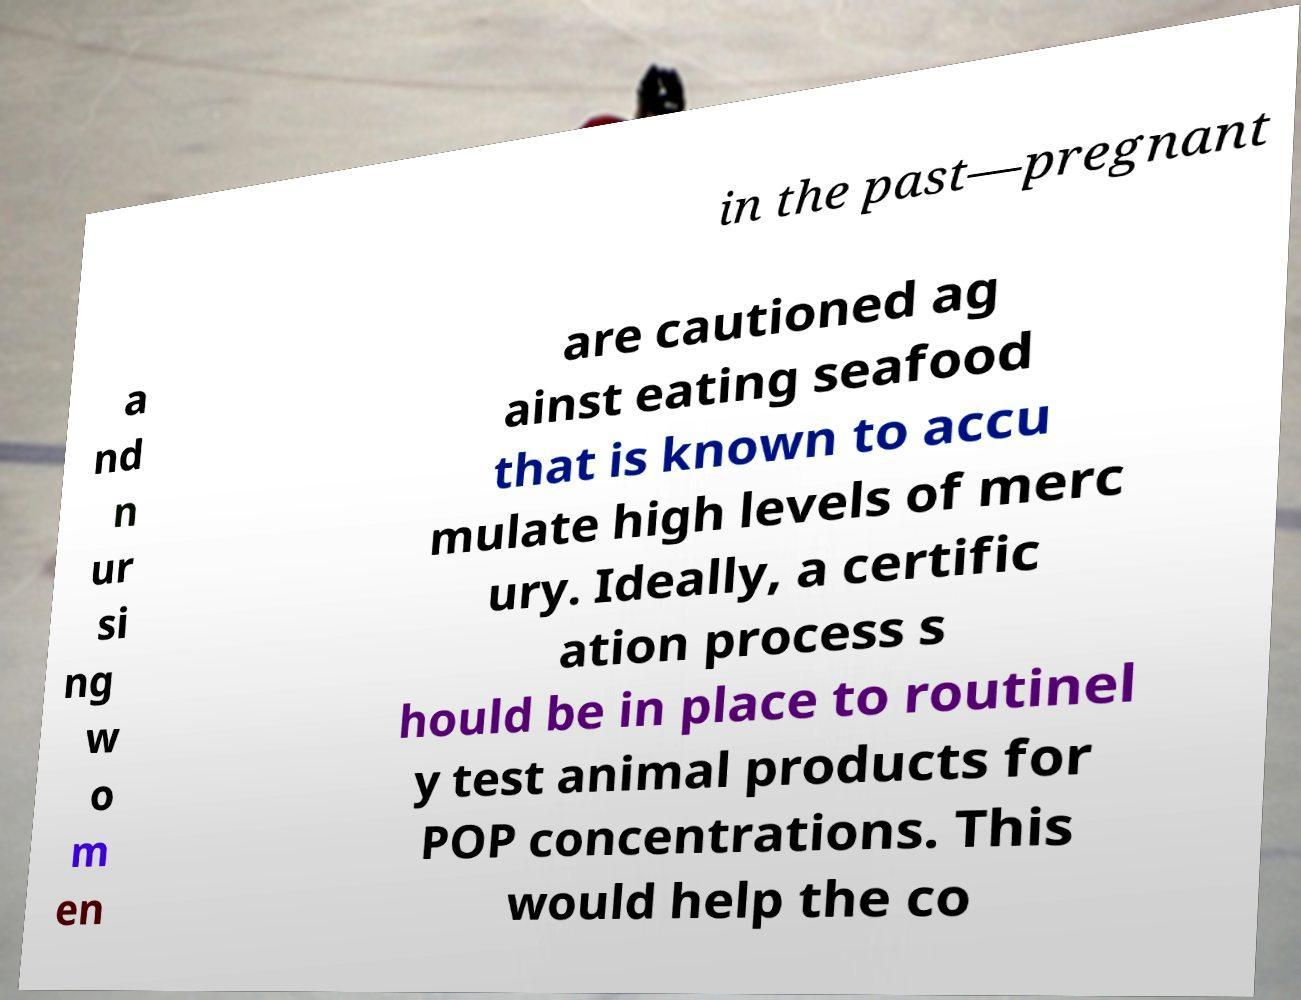Could you extract and type out the text from this image? in the past—pregnant a nd n ur si ng w o m en are cautioned ag ainst eating seafood that is known to accu mulate high levels of merc ury. Ideally, a certific ation process s hould be in place to routinel y test animal products for POP concentrations. This would help the co 